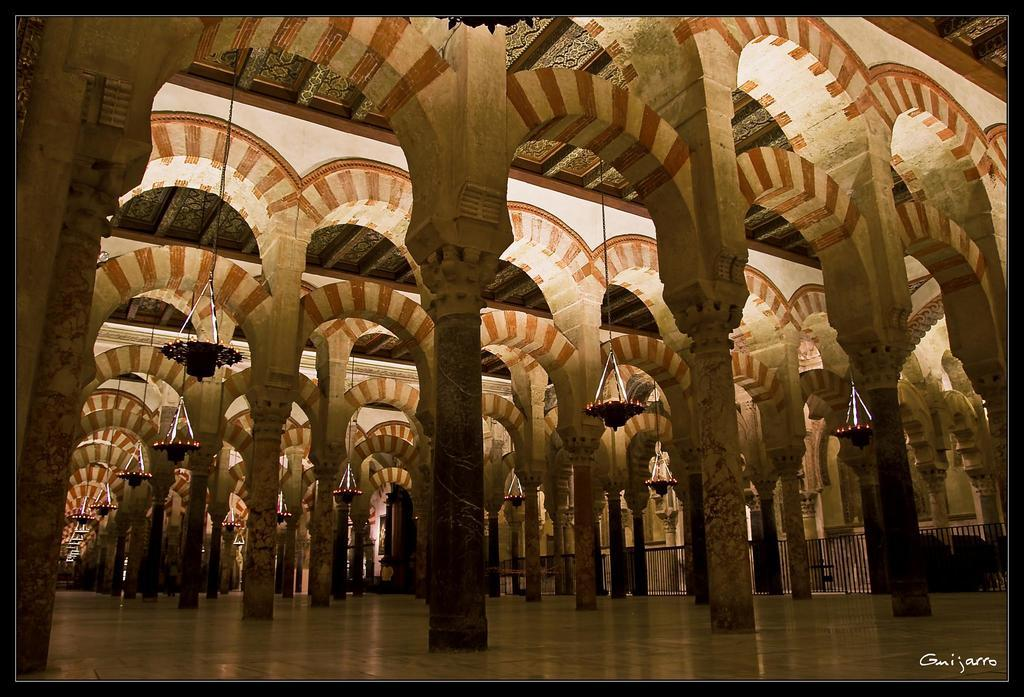What is at the bottom of the image? There is a floor at the bottom of the image. What can be seen in the middle of the image? There are pillars in the middle of the image. Where is the grandmother sitting in the image? There is no grandmother present in the image. What type of vest is being worn by the group in the image? There is no group or vest present in the image. 